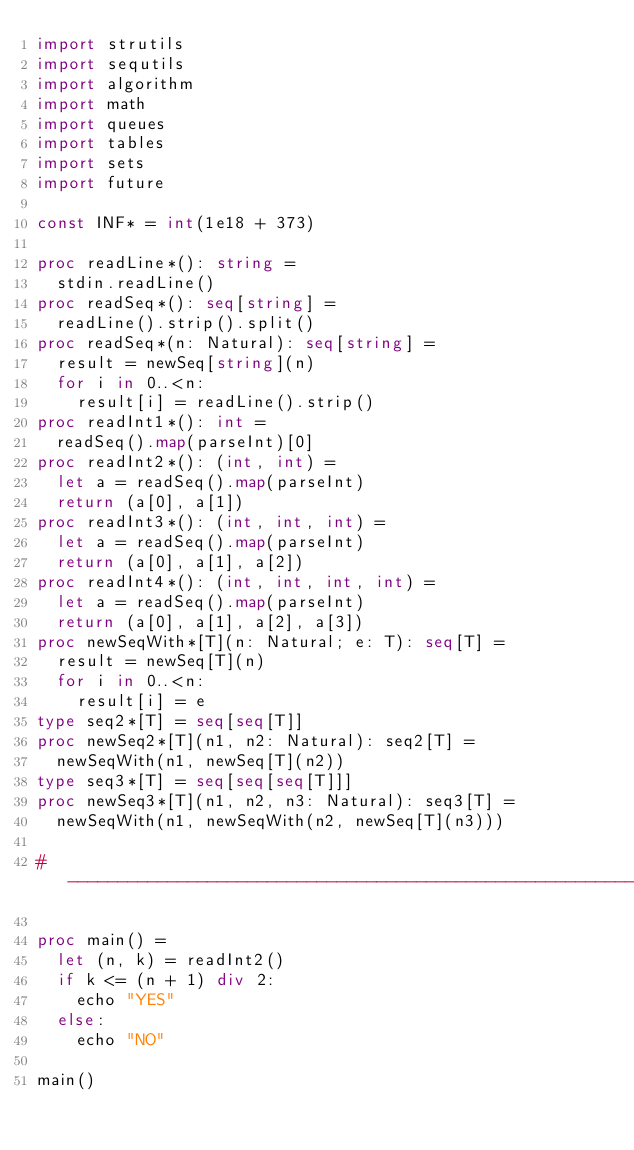Convert code to text. <code><loc_0><loc_0><loc_500><loc_500><_Nim_>import strutils
import sequtils
import algorithm
import math
import queues
import tables
import sets
import future

const INF* = int(1e18 + 373)

proc readLine*(): string =
  stdin.readLine()
proc readSeq*(): seq[string] =
  readLine().strip().split()
proc readSeq*(n: Natural): seq[string] =
  result = newSeq[string](n)
  for i in 0..<n:
    result[i] = readLine().strip()
proc readInt1*(): int =
  readSeq().map(parseInt)[0]
proc readInt2*(): (int, int) =
  let a = readSeq().map(parseInt)
  return (a[0], a[1])
proc readInt3*(): (int, int, int) =
  let a = readSeq().map(parseInt)
  return (a[0], a[1], a[2])
proc readInt4*(): (int, int, int, int) =
  let a = readSeq().map(parseInt)
  return (a[0], a[1], a[2], a[3])
proc newSeqWith*[T](n: Natural; e: T): seq[T] =
  result = newSeq[T](n)
  for i in 0..<n:
    result[i] = e
type seq2*[T] = seq[seq[T]]
proc newSeq2*[T](n1, n2: Natural): seq2[T] =
  newSeqWith(n1, newSeq[T](n2))
type seq3*[T] = seq[seq[seq[T]]]
proc newSeq3*[T](n1, n2, n3: Natural): seq3[T] =
  newSeqWith(n1, newSeqWith(n2, newSeq[T](n3)))

#------------------------------------------------------------------------------#

proc main() =
  let (n, k) = readInt2()
  if k <= (n + 1) div 2:
    echo "YES"
  else:
    echo "NO"

main()

</code> 